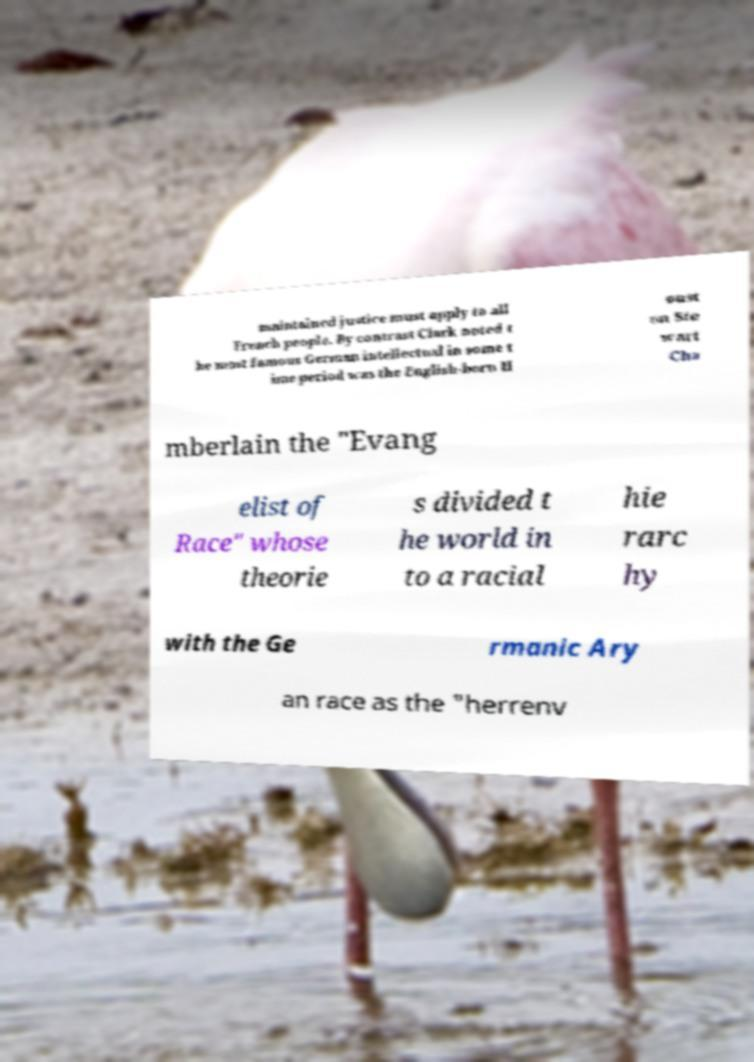For documentation purposes, I need the text within this image transcribed. Could you provide that? maintained justice must apply to all French people. By contrast Clark noted t he most famous German intellectual in some t ime period was the English-born H oust on Ste wart Cha mberlain the "Evang elist of Race" whose theorie s divided t he world in to a racial hie rarc hy with the Ge rmanic Ary an race as the "herrenv 